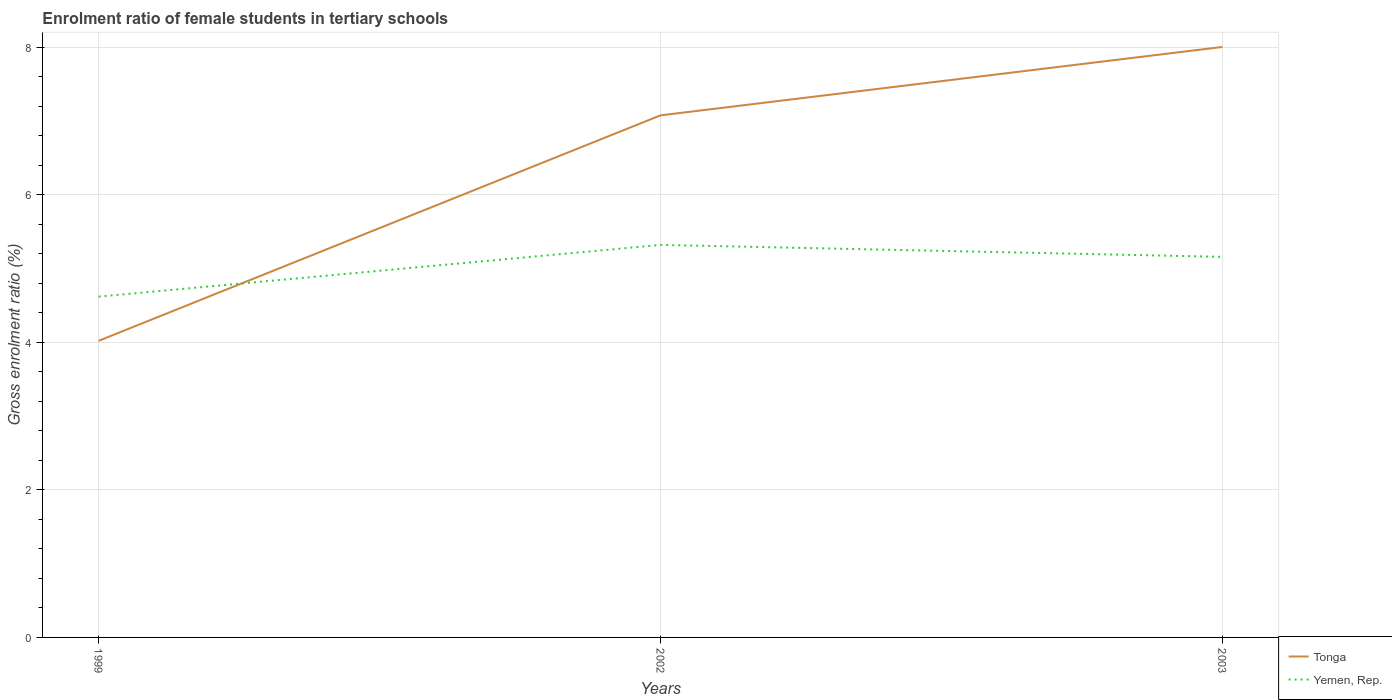Does the line corresponding to Tonga intersect with the line corresponding to Yemen, Rep.?
Keep it short and to the point. Yes. Across all years, what is the maximum enrolment ratio of female students in tertiary schools in Yemen, Rep.?
Give a very brief answer. 4.62. In which year was the enrolment ratio of female students in tertiary schools in Tonga maximum?
Provide a short and direct response. 1999. What is the total enrolment ratio of female students in tertiary schools in Yemen, Rep. in the graph?
Your answer should be very brief. 0.16. What is the difference between the highest and the second highest enrolment ratio of female students in tertiary schools in Yemen, Rep.?
Offer a terse response. 0.7. Is the enrolment ratio of female students in tertiary schools in Yemen, Rep. strictly greater than the enrolment ratio of female students in tertiary schools in Tonga over the years?
Offer a very short reply. No. How many lines are there?
Ensure brevity in your answer.  2. What is the difference between two consecutive major ticks on the Y-axis?
Give a very brief answer. 2. Does the graph contain grids?
Give a very brief answer. Yes. Where does the legend appear in the graph?
Ensure brevity in your answer.  Bottom right. How are the legend labels stacked?
Offer a very short reply. Vertical. What is the title of the graph?
Offer a very short reply. Enrolment ratio of female students in tertiary schools. Does "West Bank and Gaza" appear as one of the legend labels in the graph?
Provide a succinct answer. No. What is the label or title of the X-axis?
Provide a short and direct response. Years. What is the Gross enrolment ratio (%) in Tonga in 1999?
Provide a succinct answer. 4.02. What is the Gross enrolment ratio (%) in Yemen, Rep. in 1999?
Make the answer very short. 4.62. What is the Gross enrolment ratio (%) in Tonga in 2002?
Offer a terse response. 7.08. What is the Gross enrolment ratio (%) of Yemen, Rep. in 2002?
Make the answer very short. 5.32. What is the Gross enrolment ratio (%) of Tonga in 2003?
Your answer should be compact. 8. What is the Gross enrolment ratio (%) in Yemen, Rep. in 2003?
Make the answer very short. 5.16. Across all years, what is the maximum Gross enrolment ratio (%) of Tonga?
Your answer should be very brief. 8. Across all years, what is the maximum Gross enrolment ratio (%) of Yemen, Rep.?
Make the answer very short. 5.32. Across all years, what is the minimum Gross enrolment ratio (%) of Tonga?
Provide a short and direct response. 4.02. Across all years, what is the minimum Gross enrolment ratio (%) of Yemen, Rep.?
Your response must be concise. 4.62. What is the total Gross enrolment ratio (%) of Tonga in the graph?
Your response must be concise. 19.1. What is the total Gross enrolment ratio (%) of Yemen, Rep. in the graph?
Ensure brevity in your answer.  15.1. What is the difference between the Gross enrolment ratio (%) in Tonga in 1999 and that in 2002?
Your answer should be compact. -3.06. What is the difference between the Gross enrolment ratio (%) of Yemen, Rep. in 1999 and that in 2002?
Offer a very short reply. -0.7. What is the difference between the Gross enrolment ratio (%) in Tonga in 1999 and that in 2003?
Your answer should be compact. -3.98. What is the difference between the Gross enrolment ratio (%) of Yemen, Rep. in 1999 and that in 2003?
Provide a short and direct response. -0.54. What is the difference between the Gross enrolment ratio (%) of Tonga in 2002 and that in 2003?
Keep it short and to the point. -0.93. What is the difference between the Gross enrolment ratio (%) of Yemen, Rep. in 2002 and that in 2003?
Offer a terse response. 0.16. What is the difference between the Gross enrolment ratio (%) of Tonga in 1999 and the Gross enrolment ratio (%) of Yemen, Rep. in 2003?
Your response must be concise. -1.14. What is the difference between the Gross enrolment ratio (%) of Tonga in 2002 and the Gross enrolment ratio (%) of Yemen, Rep. in 2003?
Your answer should be very brief. 1.92. What is the average Gross enrolment ratio (%) of Tonga per year?
Offer a very short reply. 6.37. What is the average Gross enrolment ratio (%) in Yemen, Rep. per year?
Ensure brevity in your answer.  5.03. In the year 1999, what is the difference between the Gross enrolment ratio (%) in Tonga and Gross enrolment ratio (%) in Yemen, Rep.?
Provide a succinct answer. -0.6. In the year 2002, what is the difference between the Gross enrolment ratio (%) of Tonga and Gross enrolment ratio (%) of Yemen, Rep.?
Your response must be concise. 1.76. In the year 2003, what is the difference between the Gross enrolment ratio (%) in Tonga and Gross enrolment ratio (%) in Yemen, Rep.?
Your answer should be compact. 2.85. What is the ratio of the Gross enrolment ratio (%) in Tonga in 1999 to that in 2002?
Your answer should be compact. 0.57. What is the ratio of the Gross enrolment ratio (%) in Yemen, Rep. in 1999 to that in 2002?
Your answer should be very brief. 0.87. What is the ratio of the Gross enrolment ratio (%) in Tonga in 1999 to that in 2003?
Offer a very short reply. 0.5. What is the ratio of the Gross enrolment ratio (%) of Yemen, Rep. in 1999 to that in 2003?
Keep it short and to the point. 0.9. What is the ratio of the Gross enrolment ratio (%) in Tonga in 2002 to that in 2003?
Your response must be concise. 0.88. What is the ratio of the Gross enrolment ratio (%) in Yemen, Rep. in 2002 to that in 2003?
Provide a short and direct response. 1.03. What is the difference between the highest and the second highest Gross enrolment ratio (%) of Tonga?
Your answer should be compact. 0.93. What is the difference between the highest and the second highest Gross enrolment ratio (%) of Yemen, Rep.?
Give a very brief answer. 0.16. What is the difference between the highest and the lowest Gross enrolment ratio (%) of Tonga?
Offer a terse response. 3.98. What is the difference between the highest and the lowest Gross enrolment ratio (%) of Yemen, Rep.?
Offer a very short reply. 0.7. 